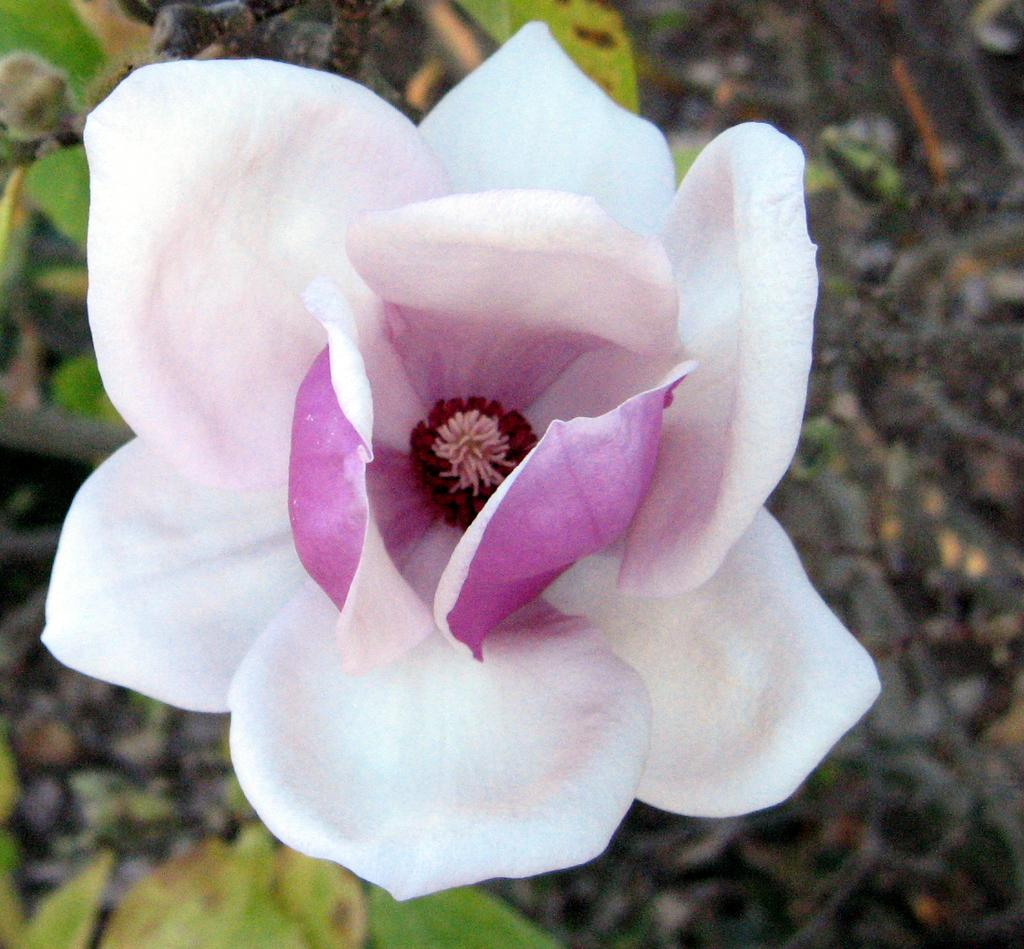What is the main subject of the image? There is a flower in the image. How many boys are holding the brain of the bear in the image? There are no boys, brains, or bears present in the image; it features a flower. 